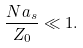<formula> <loc_0><loc_0><loc_500><loc_500>\frac { N a _ { s } } { Z _ { 0 } } \ll 1 .</formula> 